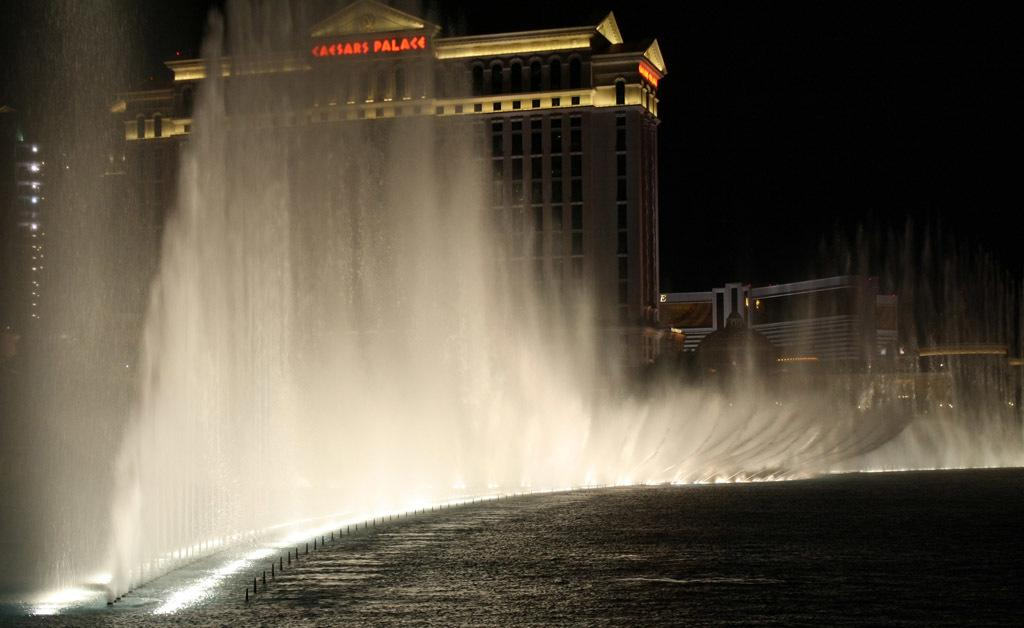What can be seen in the river in the image? There are water fountains in the river. What is visible in the background of the image? There are buildings in the background of the image. How would you describe the sky in the image? The sky is completely dark in the image. What type of vegetable is being used as a vase for the flowers in the image? There are no flowers or vases present in the image; it features water fountains in a river and buildings in the background. 